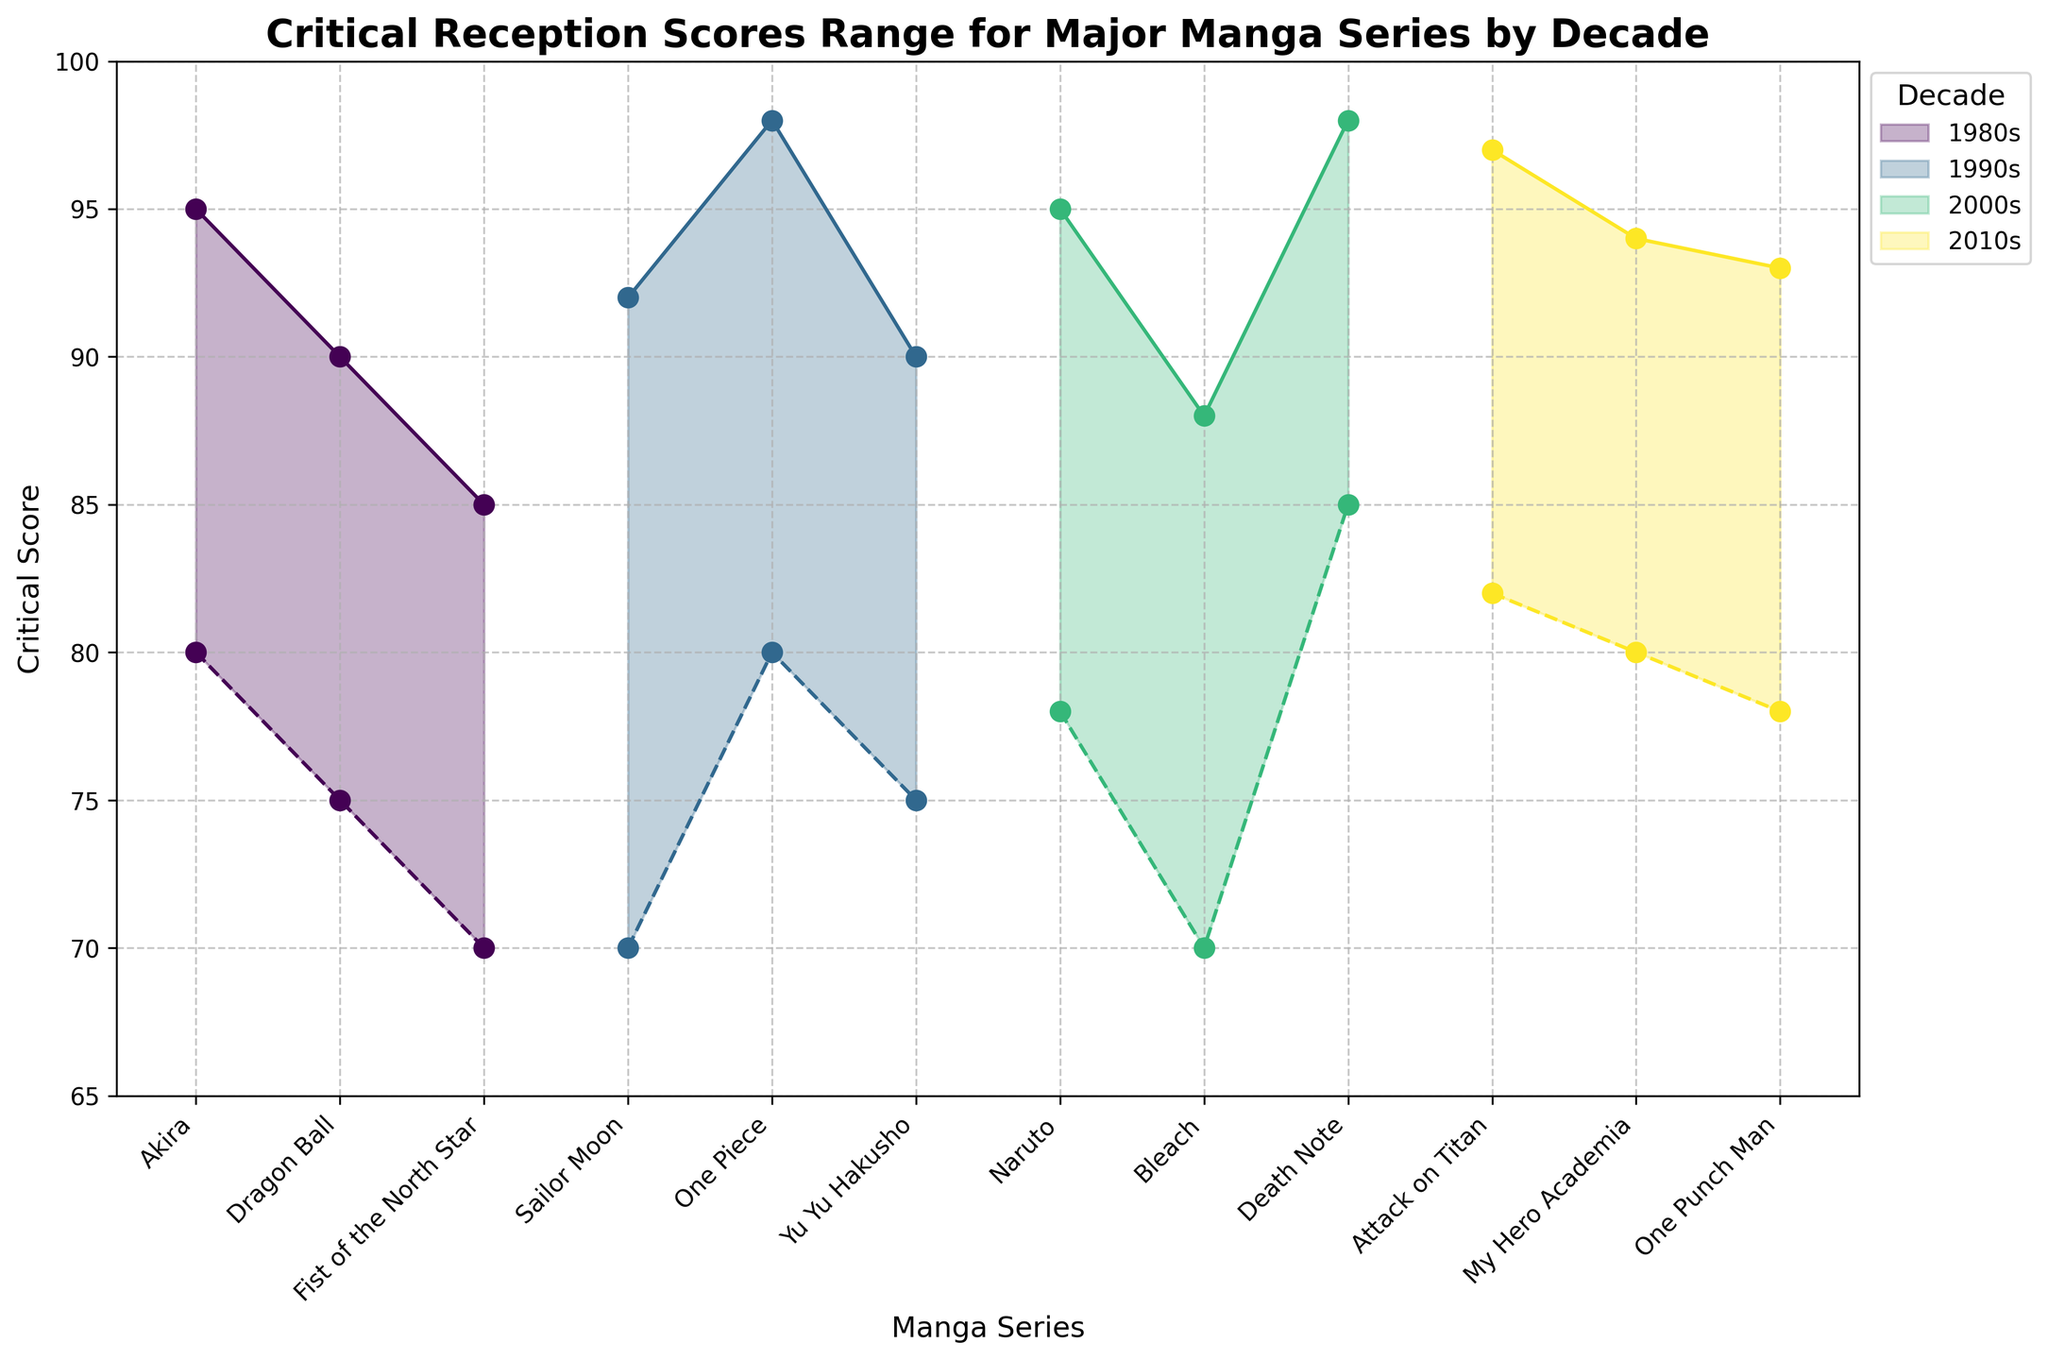What's the title of the chart? The chart title is located at the top of the figure. It summarizes the main topic of the figure. The title is "Critical Reception Scores Range for Major Manga Series by Decade."
Answer: Critical Reception Scores Range for Major Manga Series by Decade How many manga series are listed from the 1990s? To find this, look at the series of points corresponding to the 1990s labeled in the plot legend. Count the number of data points for that decade. There are three manga series listed.
Answer: 3 Which manga series from the 1980s has the highest maximum score? Locate all the manga series from the 1980s by checking their scores within the respective decade's color shade. Compare the maximum scores of Akira, Dragon Ball, and Fist of the North Star. Akira has the highest maximum score of 95.
Answer: Akira Among the manga series from the 2000s, which has the narrowest range of scores? Identify the 2000s' manga series and calculate the score range (Max Score - Min Score) for Naruto, Bleach, and Death Note. Death Note has the range (98-85) = 13, which is narrower than the ranges for Naruto (95-78) = 17 and Bleach (88-70) = 18.
Answer: Death Note Which decade features the manga series with the lowest minimum score? Observe the lowest points in each color-coded time range. The 1980s series include a manga with the lowest minimum score of 70 (Fist of the North Star). No series in subsequent decades falls below this score.
Answer: 1980s Which manga series from the 2010s has the highest minimum score? Look for the highest minimum score value for series from the 2010s. Attack on Titan has the highest minimum score of 82 among My Hero Academia (80) and One Punch Man (78).
Answer: Attack on Titan Compare the score ranges of Dragon Ball and My Hero Academia and identify which has the larger range. Find the Min and Max scores for Dragon Ball (75-90) and My Hero Academia (80-94), and calculate the ranges. Dragon Ball's range is 90-75=15, and My Hero Academia's range is 94-80=14. Dragon Ball has the larger range.
Answer: Dragon Ball What is the average maximum score for the manga series from the 2000s? Calculate the average of the max scores for Naruto, Bleach, and Death Note. Sum their max scores (95+88+98) = 281. Divide by the number of series (3), resulting in an average of 281/3 = 93.67.
Answer: 93.67 Identify the manga series that falls within the 85 to 95 score range for both the minimum and maximum scores. Examine which manga series have both min and max scores within the 85-95 range. Given the conditions, only Akira (80-95) satisfies this range.
Answer: Akira 